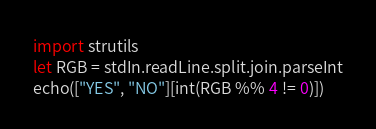<code> <loc_0><loc_0><loc_500><loc_500><_Nim_>import strutils
let RGB = stdIn.readLine.split.join.parseInt
echo(["YES", "NO"][int(RGB %% 4 != 0)])
</code> 